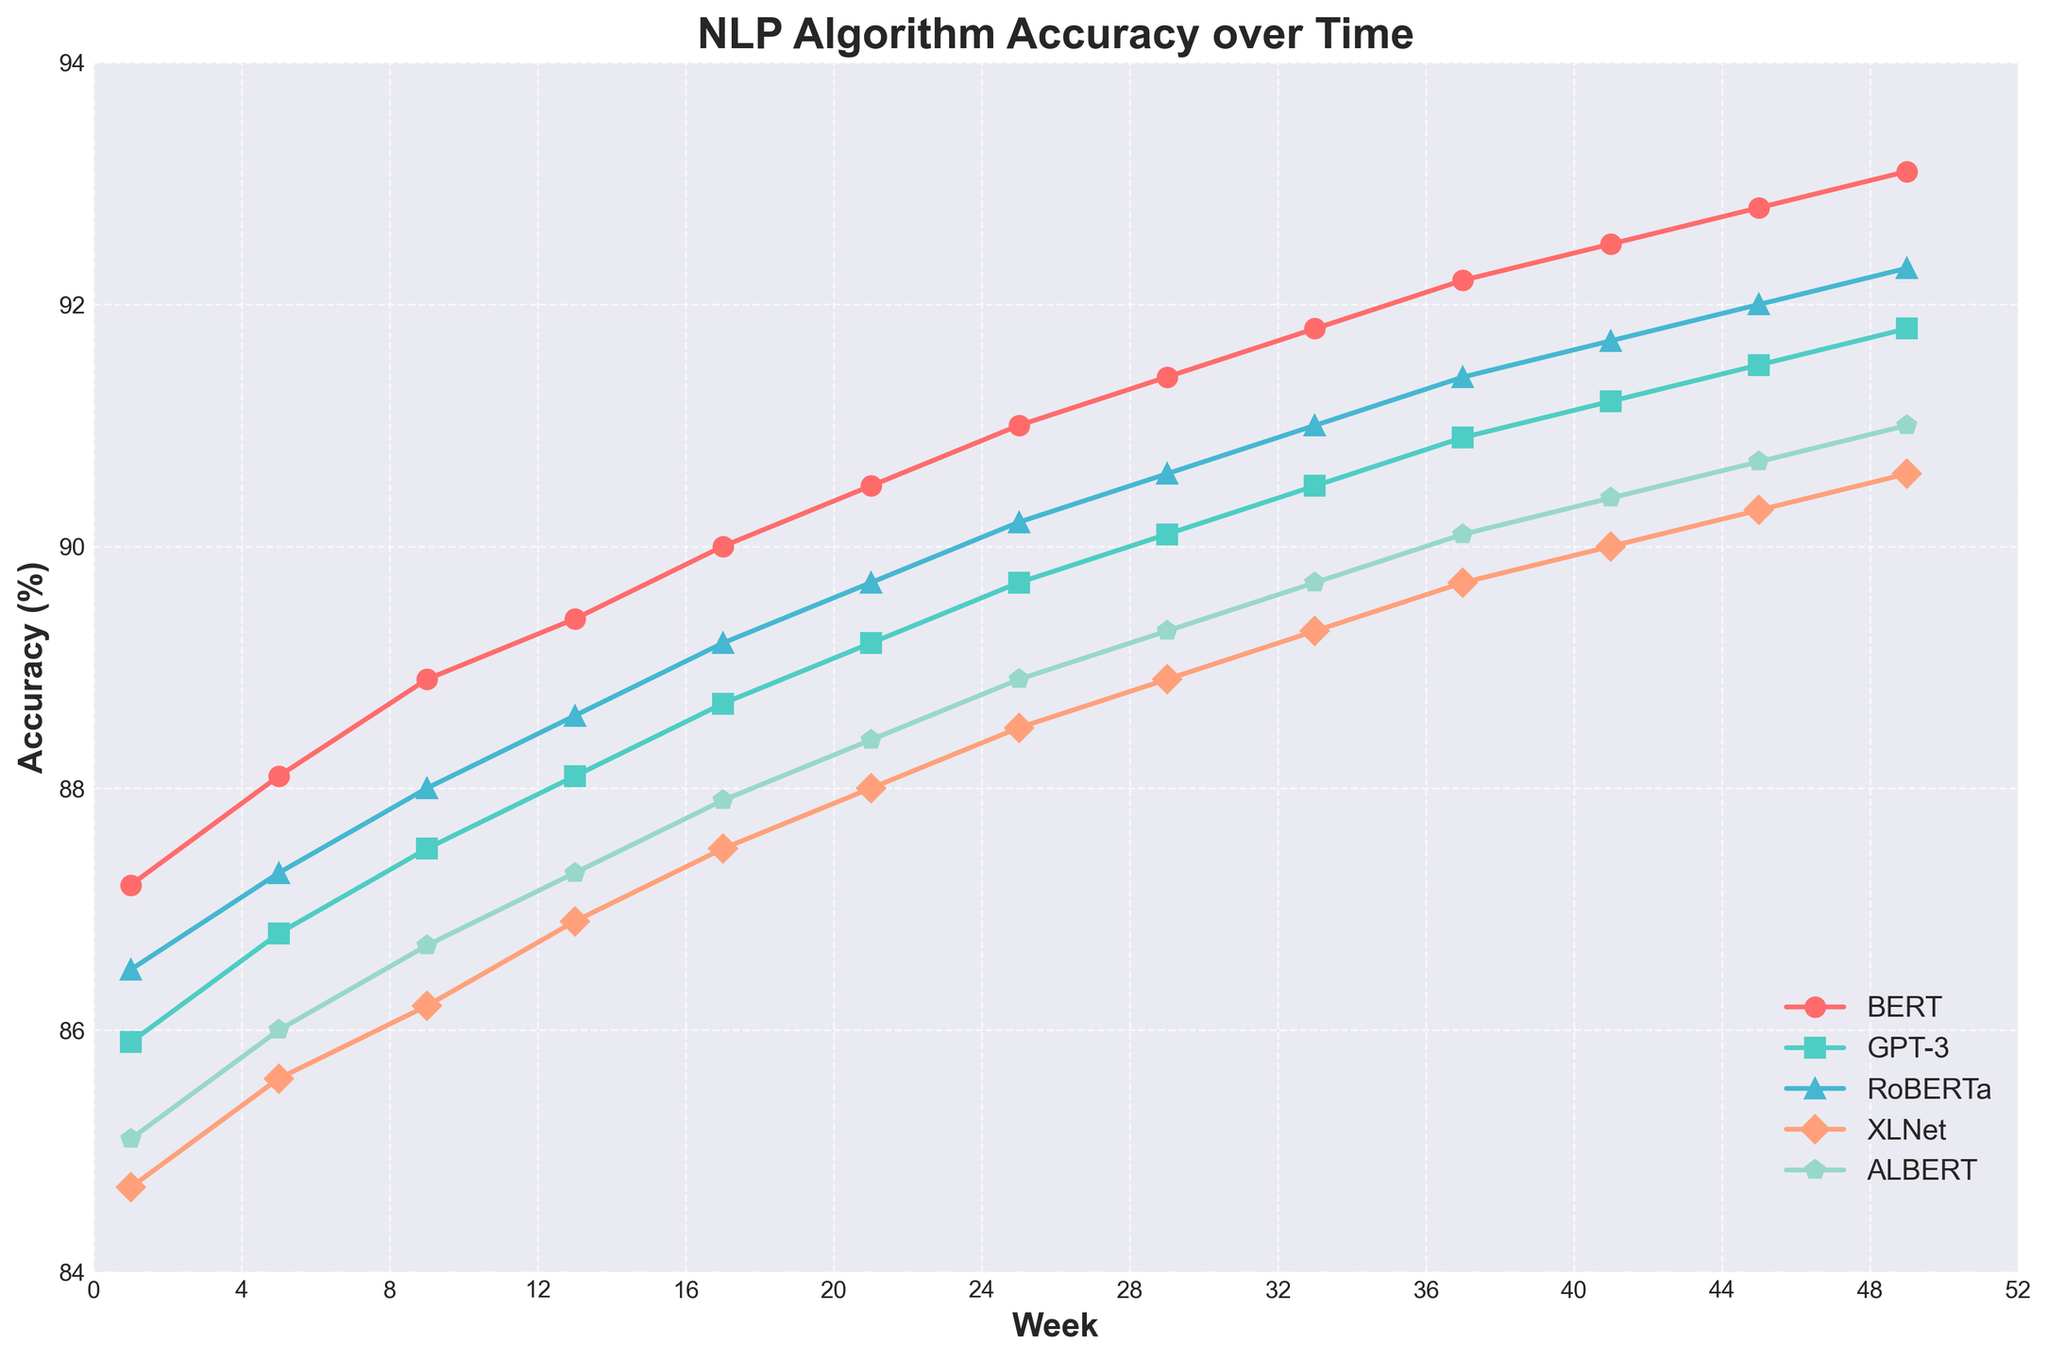Which algorithm has the highest accuracy at week 49? To find the algorithm with the highest accuracy at week 49, look at the 49th data point on the x-axis and compare the y-values (accuracy rates) of all five algorithms. The algorithm represented by the highest y-value is the one with the highest accuracy.
Answer: BERT How does the accuracy of GPT-3 change from week 5 to week 25? To determine the change in GPT-3's accuracy from week 5 to week 25, locate the accuracy values for GPT-3 at weeks 5 and 25 and calculate the difference. The accuracy is 86.8% at week 5 and 89.7% at week 25; thus, the increase is 89.7% - 86.8% = 2.9%.
Answer: It increased by 2.9% Between RoBERTa and ALBERT, which algorithm shows greater improvement in accuracy from week 1 to week 49? To compare improvements in accuracy, find the accuracy at the start (week 1) and the end (week 49) for both RoBERTa and ALBERT. Calculate the increase for each: RoBERTa improves from 86.5% to 92.3% (5.8%) and ALBERT improves from 85.1% to 91.0% (5.9%).
Answer: ALBERT At week 21, which algorithm has the lowest accuracy? To find the algorithm with the lowest accuracy at week 21, look at the accuracy values of all five algorithms at week 21. The lowest y-value among those data points will indicate the algorithm with the lowest accuracy.
Answer: XLNet How many weeks does it take for XLNet to surpass 90% accuracy? To determine the number of weeks it takes XLNet to surpass 90% accuracy, locate the weeks on the x-axis where the accuracy crosses the 90% mark. The data shows XLNet does not surpass 90% within the observed period (up to week 49).
Answer: XLNet does not surpass 90% What is the overall trend in accuracy for BERT over the year? To describe the overall trend in BERT's accuracy, look at the slope of BERT's line from week 1 to week 49. It starts at 87.2% and ends at 93.1%, showing a consistent upward trend throughout the year.
Answer: Upward trend Compare the accuracy rates of GPT-3 and RoBERTa at week 33. To compare the accuracy rates of GPT-3 and RoBERTa at week 33, locate their respective values at week 33 on the x-axis. GPT-3 has an accuracy of 90.5%, while RoBERTa has 91.0%.
Answer: RoBERTa is higher What is the average accuracy of BERT from week 1 to week 49? To calculate the average accuracy of BERT from week 1 to week 49, sum the accuracy values at each sampled week (1, 5, 9, ..., 49) and divide by the number of weeks (12). The values are: 87.2, 88.1, 88.9, 89.4, 90.0, 90.5, 91.0, 91.4, 91.8, 92.2, 92.5, 92.8, 93.1. The sum is 1097.9; the average is 1097.9 / 12.
Answer: 91.49% Which two algorithms are closest in accuracy at week 41? At week 41, find the accuracies for all algorithms and then determine the pair with the smallest difference. The accuracies at week 41 are BERT: 92.5%, GPT-3: 91.2%, RoBERTa: 91.7%, XLNet: 90.0%, ALBERT: 90.4%. The closest pair is GPT-3 and RoBERTa with a difference of 0.5% (91.7% - 91.2%).
Answer: GPT-3 and RoBERTa 